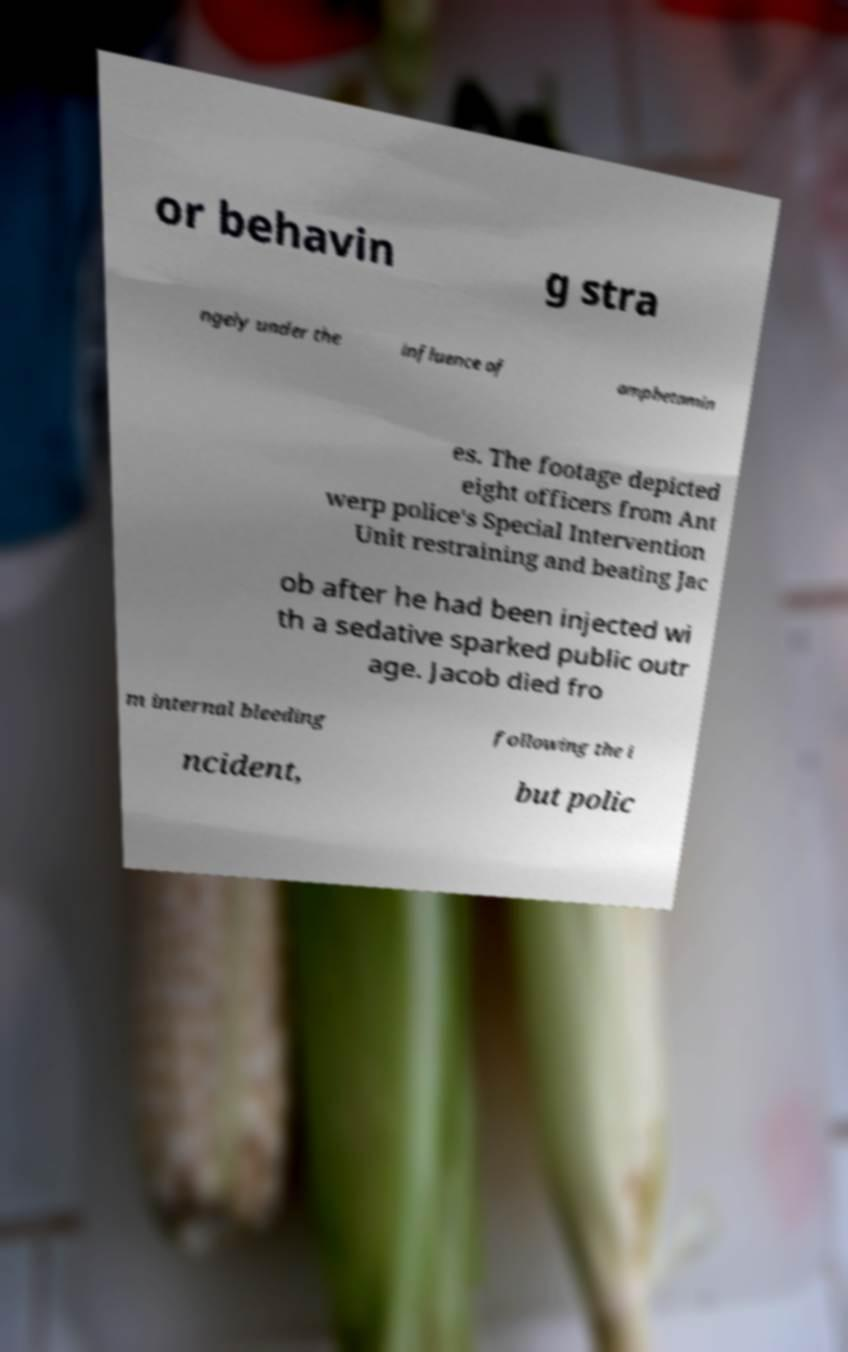Could you extract and type out the text from this image? or behavin g stra ngely under the influence of amphetamin es. The footage depicted eight officers from Ant werp police's Special Intervention Unit restraining and beating Jac ob after he had been injected wi th a sedative sparked public outr age. Jacob died fro m internal bleeding following the i ncident, but polic 